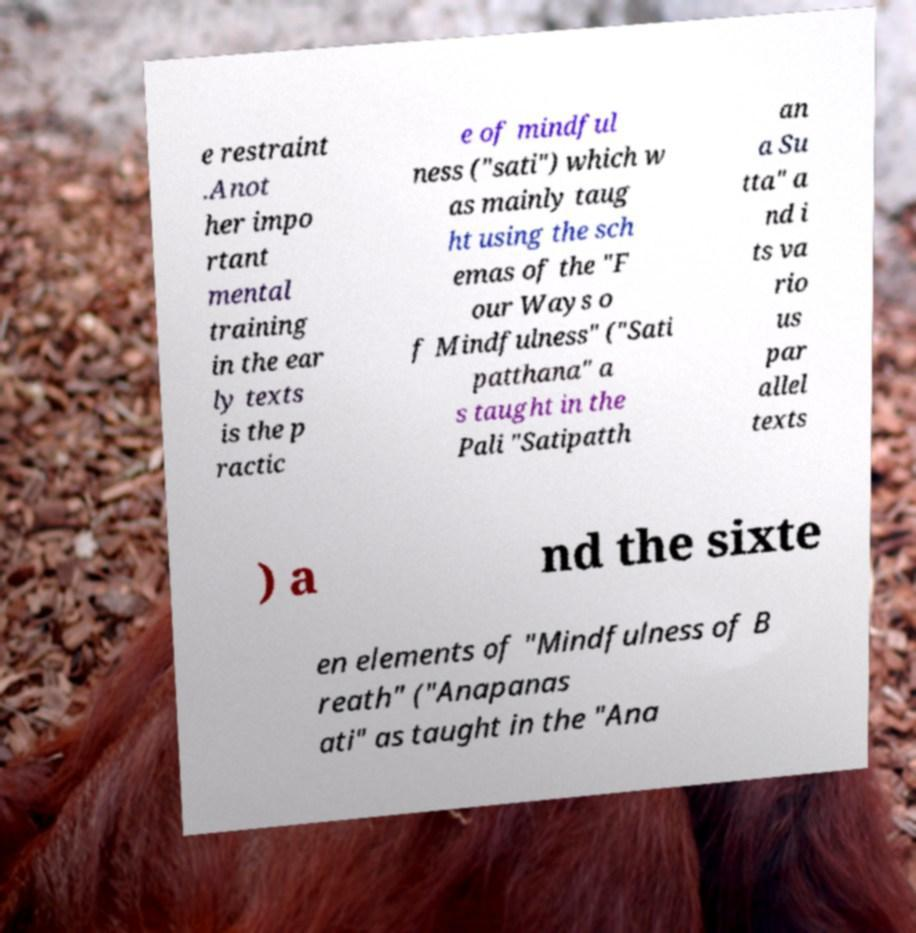Could you extract and type out the text from this image? e restraint .Anot her impo rtant mental training in the ear ly texts is the p ractic e of mindful ness ("sati") which w as mainly taug ht using the sch emas of the "F our Ways o f Mindfulness" ("Sati patthana" a s taught in the Pali "Satipatth an a Su tta" a nd i ts va rio us par allel texts ) a nd the sixte en elements of "Mindfulness of B reath" ("Anapanas ati" as taught in the "Ana 